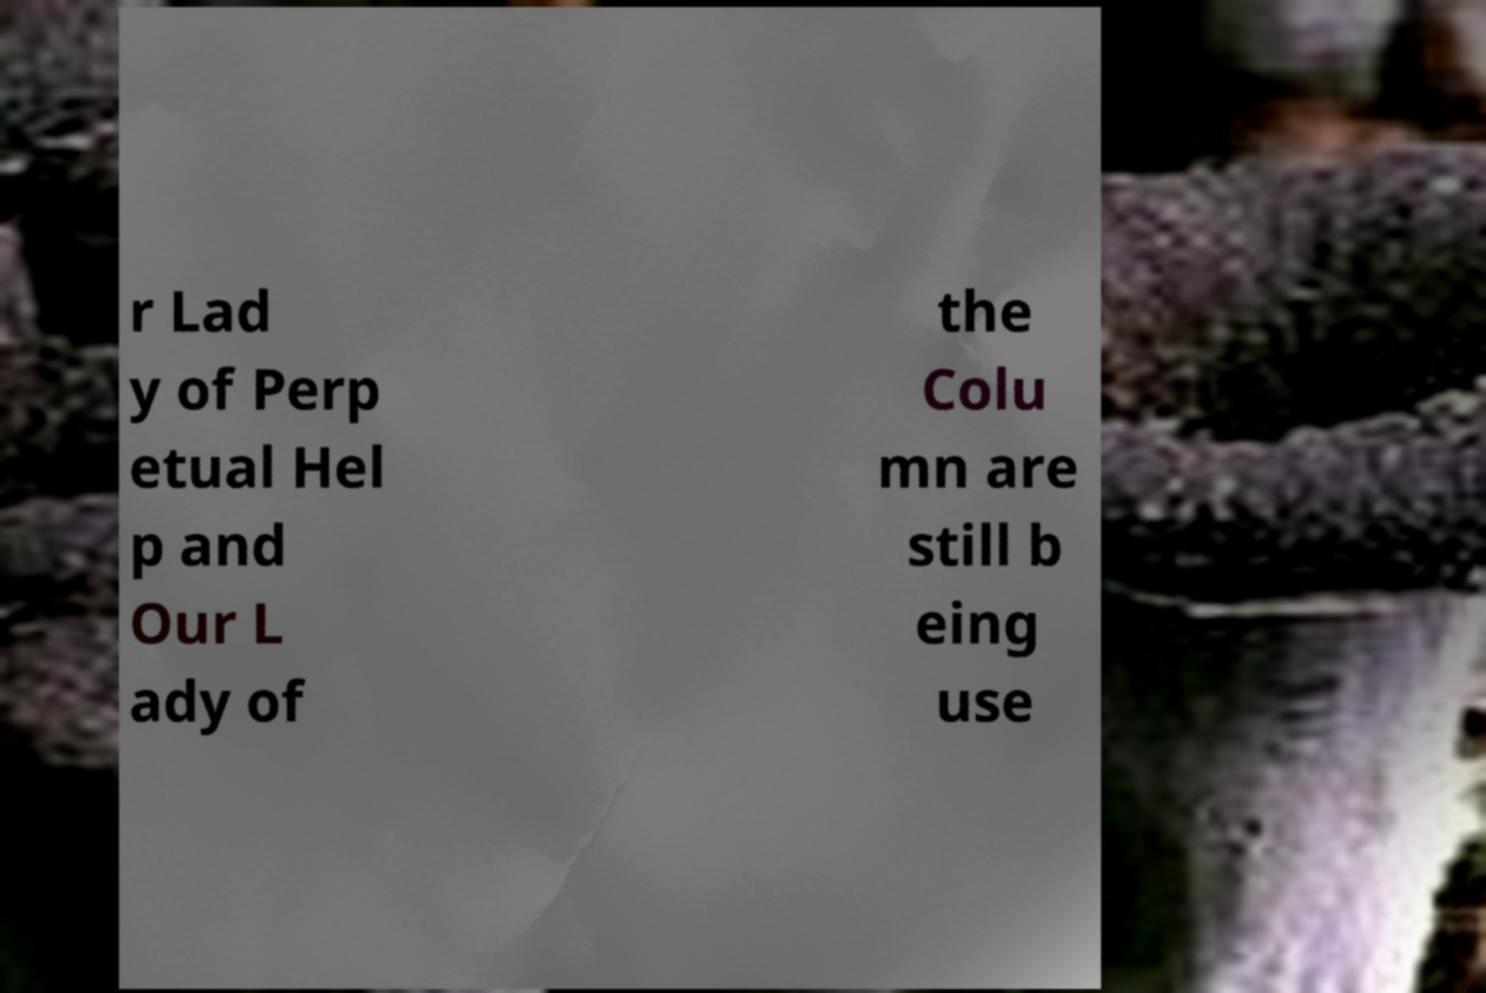Can you read and provide the text displayed in the image?This photo seems to have some interesting text. Can you extract and type it out for me? r Lad y of Perp etual Hel p and Our L ady of the Colu mn are still b eing use 